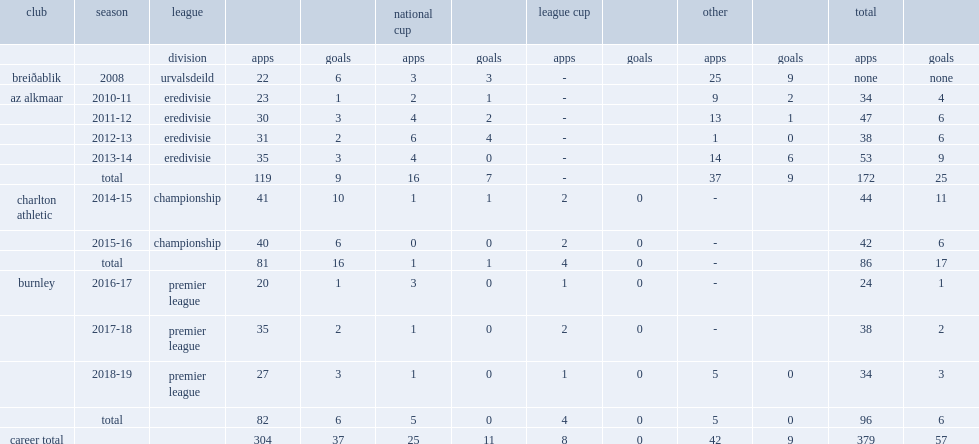In 2008, which league did johann berg guðmundsson play for breiðablik? Urvalsdeild. 